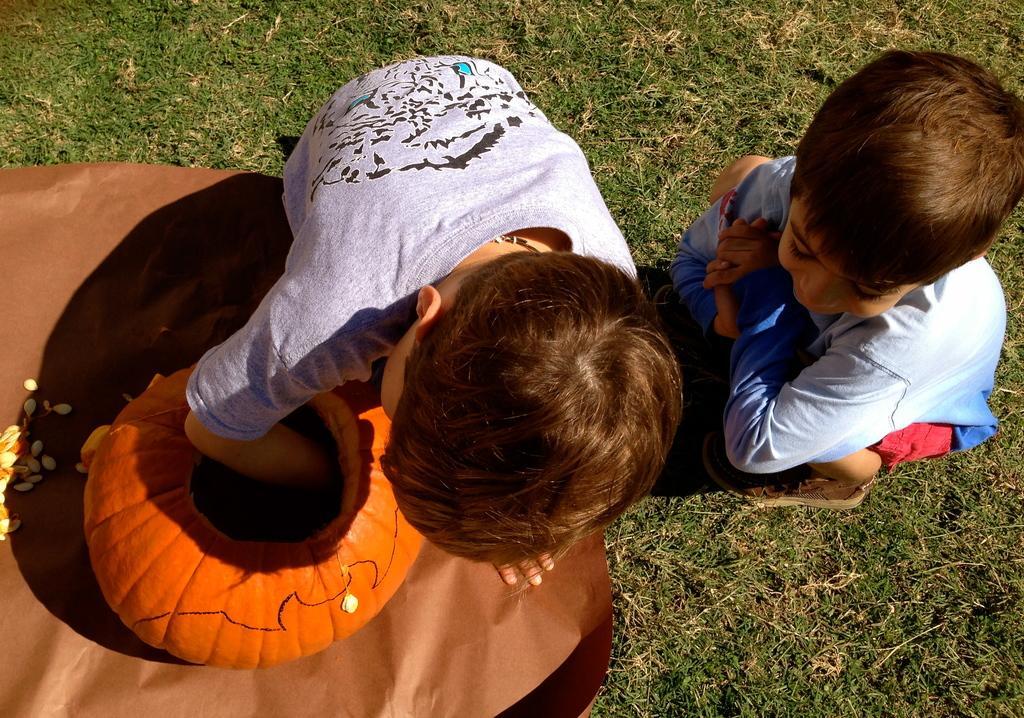Could you give a brief overview of what you see in this image? In this image, there are a few people. We can see the ground covered with grass and some objects. We can also see a pot and some seeds. 